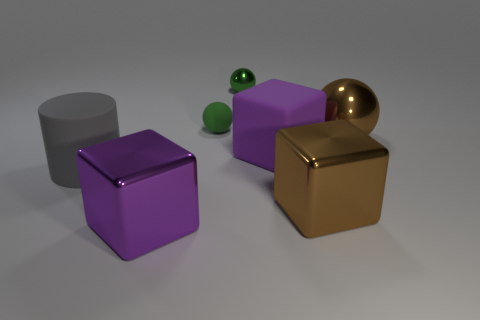There is a sphere that is the same material as the gray object; what is its size?
Give a very brief answer. Small. Are there more purple matte blocks than tiny green shiny cylinders?
Keep it short and to the point. Yes. There is a shiny object that is left of the tiny green rubber object; what color is it?
Your answer should be very brief. Purple. There is a metallic object that is behind the large purple rubber cube and in front of the green metal object; what size is it?
Offer a terse response. Large. How many yellow cubes are the same size as the green metallic ball?
Your answer should be compact. 0. There is another tiny green object that is the same shape as the green metallic thing; what is it made of?
Provide a short and direct response. Rubber. Is the big purple metal object the same shape as the big purple matte thing?
Provide a short and direct response. Yes. There is a big gray object; what number of large brown blocks are on the right side of it?
Ensure brevity in your answer.  1. What is the shape of the big purple thing that is to the right of the big purple thing that is left of the green matte ball?
Your answer should be very brief. Cube. What is the shape of the big object that is the same material as the cylinder?
Your response must be concise. Cube. 